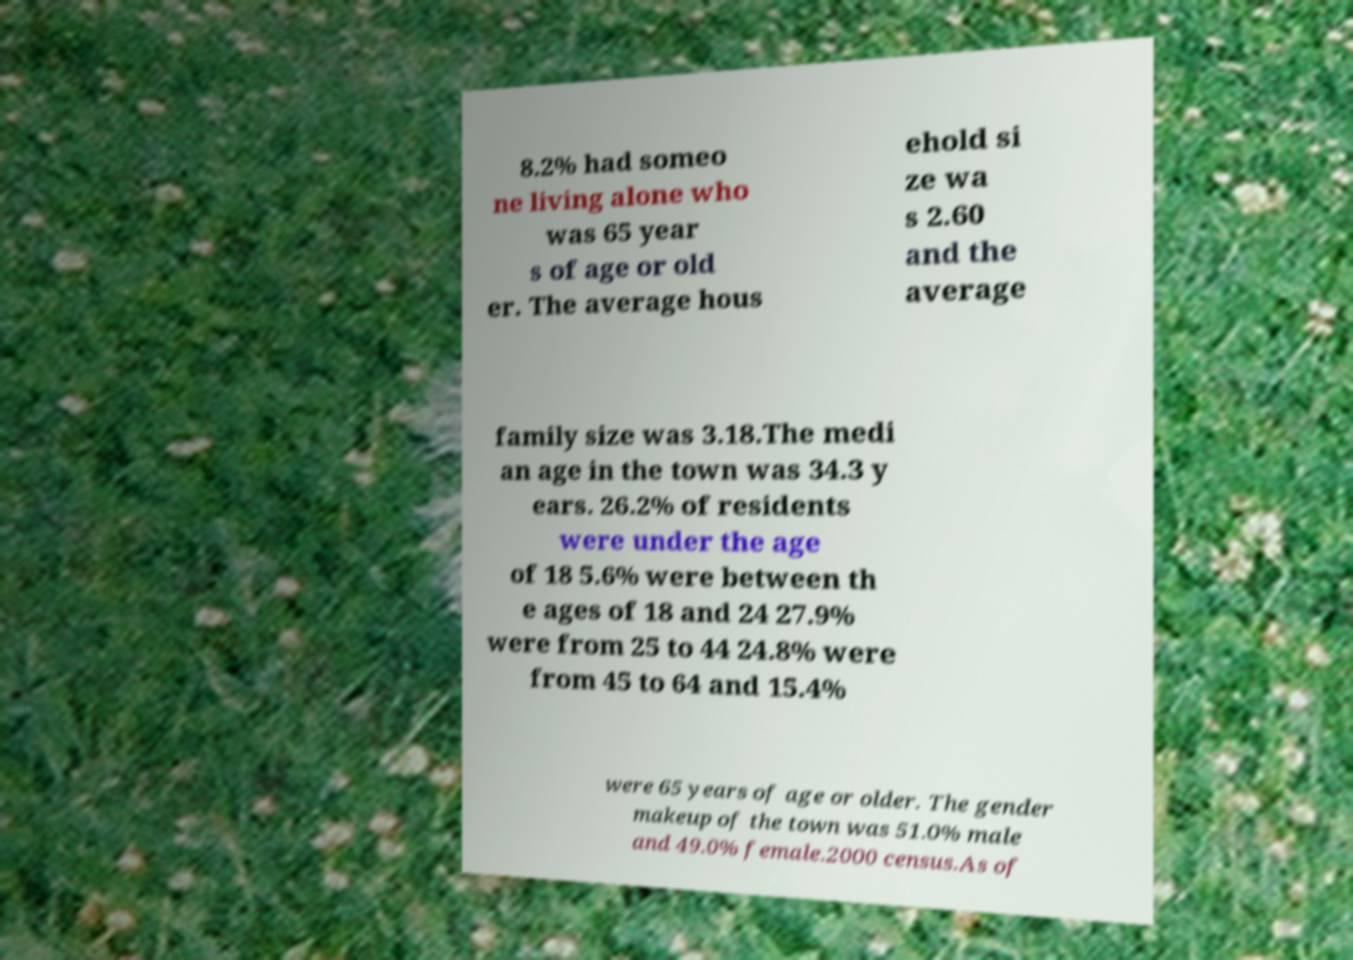Please identify and transcribe the text found in this image. 8.2% had someo ne living alone who was 65 year s of age or old er. The average hous ehold si ze wa s 2.60 and the average family size was 3.18.The medi an age in the town was 34.3 y ears. 26.2% of residents were under the age of 18 5.6% were between th e ages of 18 and 24 27.9% were from 25 to 44 24.8% were from 45 to 64 and 15.4% were 65 years of age or older. The gender makeup of the town was 51.0% male and 49.0% female.2000 census.As of 